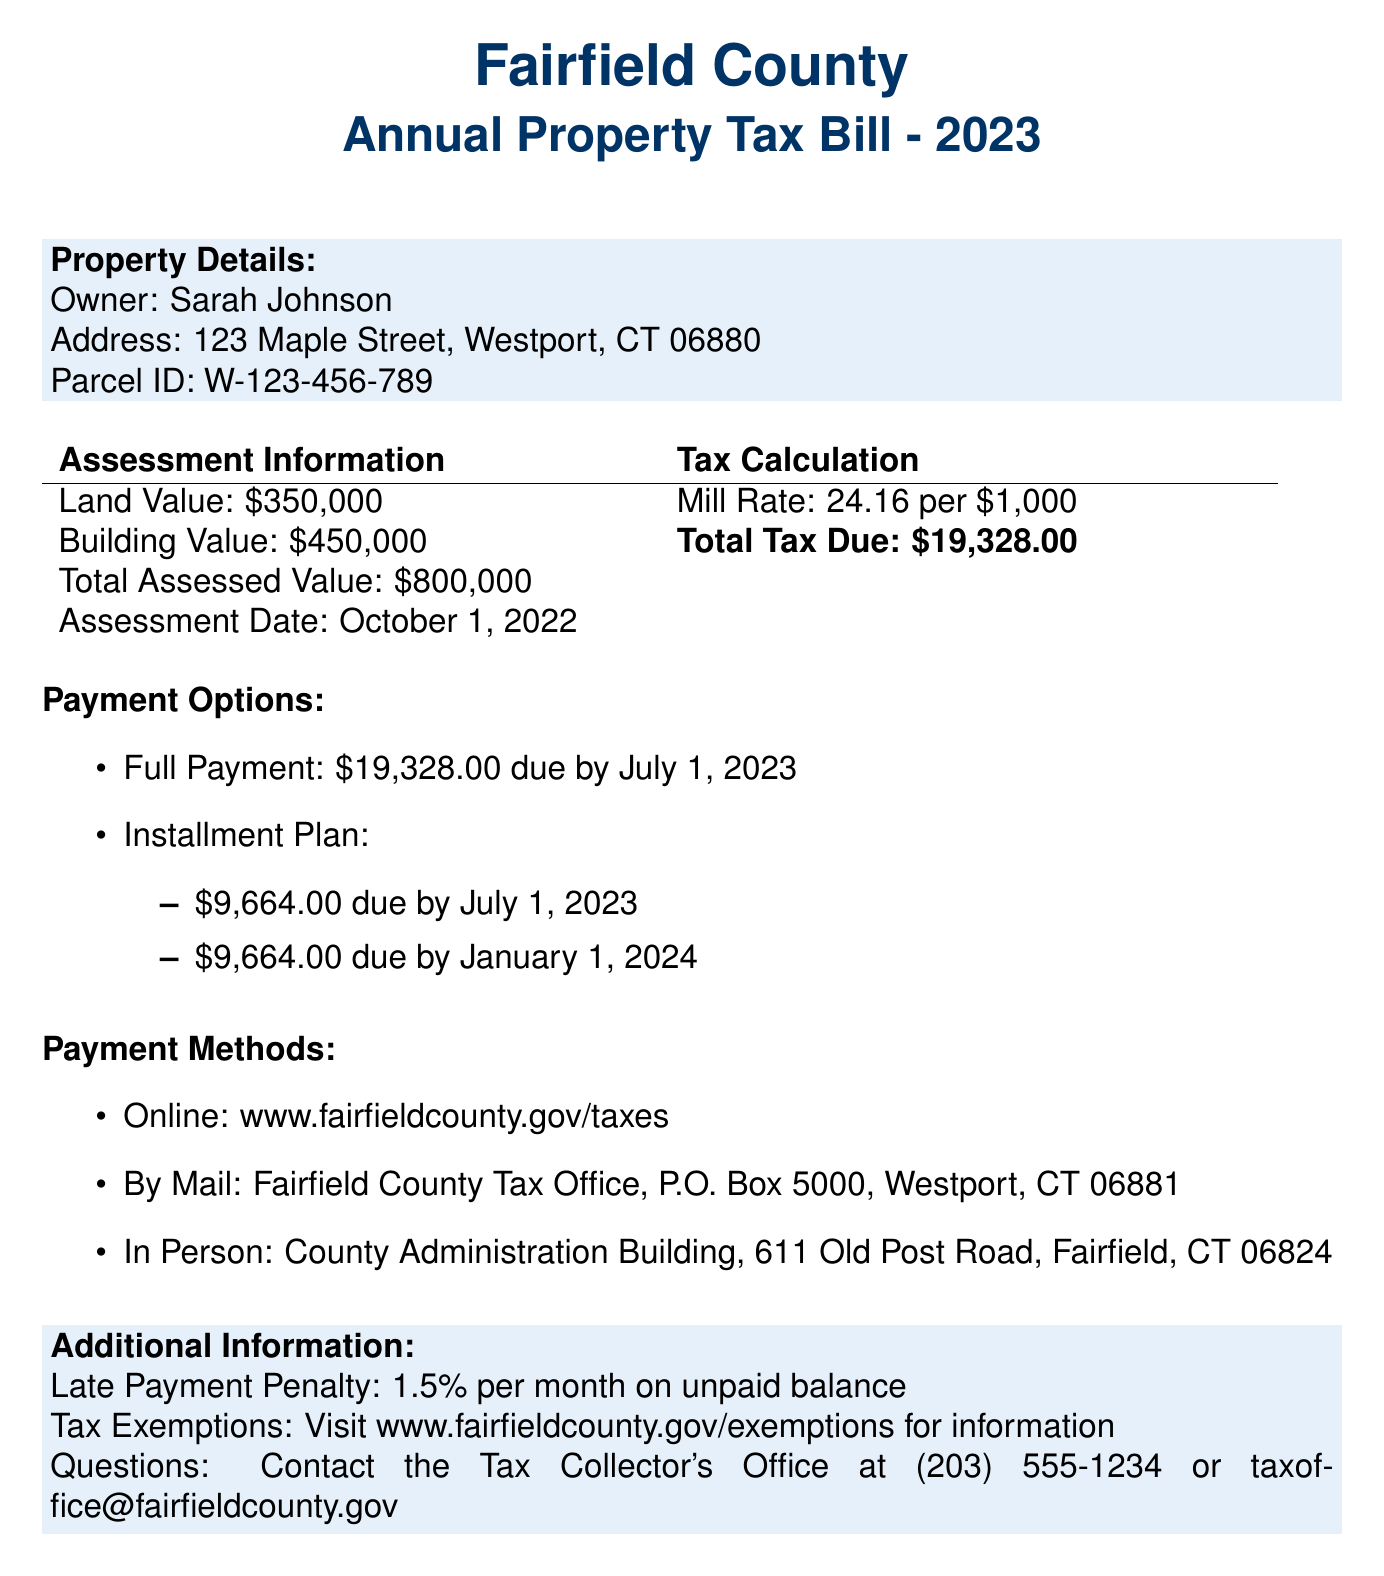What is the owner's name? The owner's name is listed in the property details section of the document.
Answer: Sarah Johnson What is the total assessed value of the property? The total assessed value is stated in the assessment information table.
Answer: \$800,000 What is the mill rate? The mill rate is provided in the tax calculation section of the document.
Answer: 24.16 per \$1,000 When is the full payment due? The due date for full payment is mentioned in the payment options section.
Answer: July 1, 2023 What are the two due amounts for the installment plan? The installment plan details two due amounts listed under payment options.
Answer: \$9,664.00, \$9,664.00 What is the penalty for late payment? The late payment penalty is specified in the additional information section.
Answer: 1.5% per month Where can I make an online payment? The online payment website is provided in the payment methods section.
Answer: www.fairfieldcounty.gov/taxes What is the contact for questions regarding the tax bill? Contact information is listed in the additional information section.
Answer: (203) 555-1234 or taxoffice@fairfieldcounty.gov 